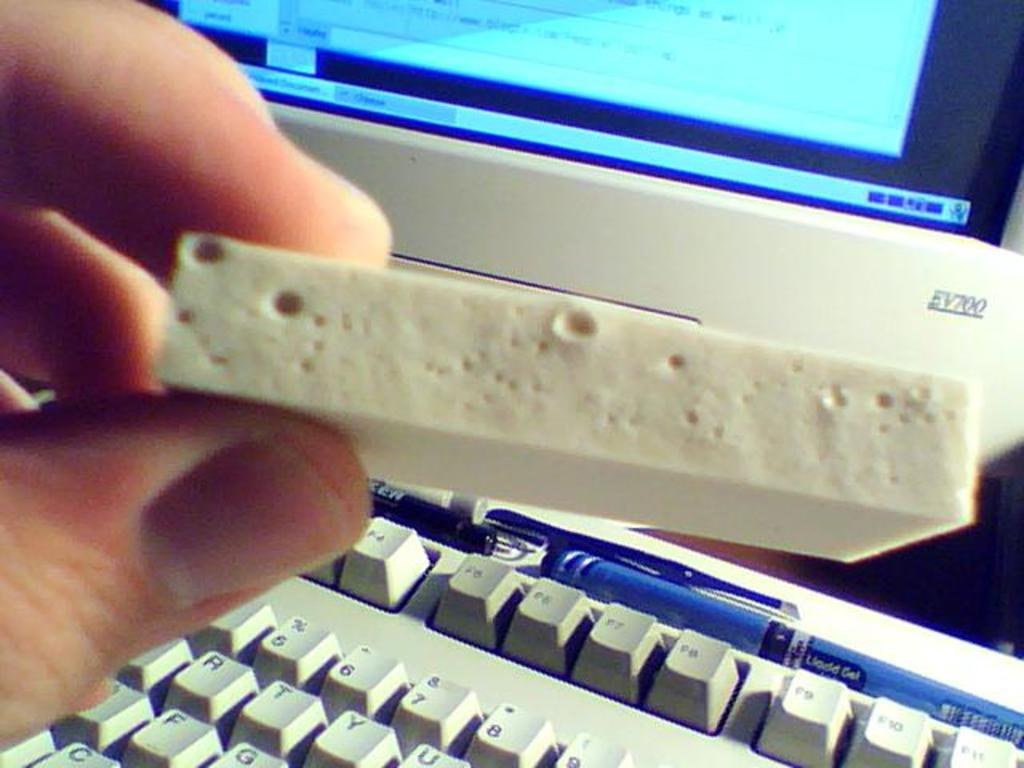<image>
Relay a brief, clear account of the picture shown. A blue liquid gel pen rests on top of the function keys of a keyboard. 